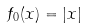Convert formula to latex. <formula><loc_0><loc_0><loc_500><loc_500>f _ { 0 } ( x ) = | x |</formula> 